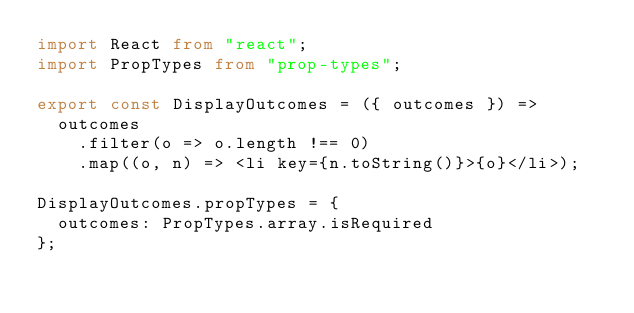Convert code to text. <code><loc_0><loc_0><loc_500><loc_500><_TypeScript_>import React from "react";
import PropTypes from "prop-types";

export const DisplayOutcomes = ({ outcomes }) =>
  outcomes
    .filter(o => o.length !== 0)
    .map((o, n) => <li key={n.toString()}>{o}</li>);

DisplayOutcomes.propTypes = {
  outcomes: PropTypes.array.isRequired
};
</code> 